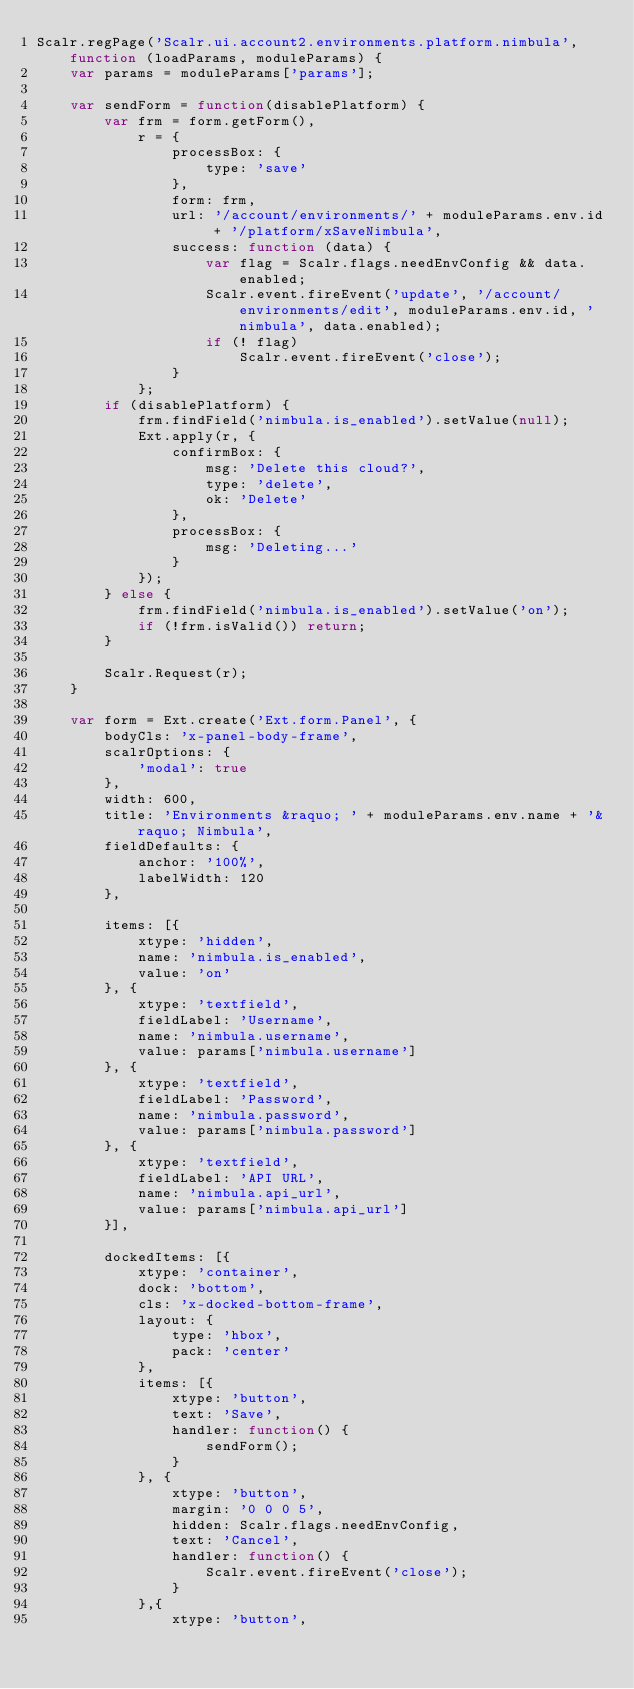Convert code to text. <code><loc_0><loc_0><loc_500><loc_500><_JavaScript_>Scalr.regPage('Scalr.ui.account2.environments.platform.nimbula', function (loadParams, moduleParams) {
	var params = moduleParams['params'];

	var sendForm = function(disablePlatform) {
		var frm = form.getForm(),
			r = {
				processBox: {
					type: 'save'
				},
				form: frm,
				url: '/account/environments/' + moduleParams.env.id + '/platform/xSaveNimbula',
				success: function (data) {
					var flag = Scalr.flags.needEnvConfig && data.enabled;
					Scalr.event.fireEvent('update', '/account/environments/edit', moduleParams.env.id, 'nimbula', data.enabled);
					if (! flag)
						Scalr.event.fireEvent('close');
				}
			};
		if (disablePlatform) {
			frm.findField('nimbula.is_enabled').setValue(null);
			Ext.apply(r, {
				confirmBox: {
					msg: 'Delete this cloud?',
					type: 'delete',
					ok: 'Delete'
				},
				processBox: {
					msg: 'Deleting...'
				}
			});
		} else {
			frm.findField('nimbula.is_enabled').setValue('on');
			if (!frm.isValid()) return;
		}
		
		Scalr.Request(r);
	}
	
	var form = Ext.create('Ext.form.Panel', {
		bodyCls: 'x-panel-body-frame',
		scalrOptions: {
			'modal': true
		},
		width: 600,
		title: 'Environments &raquo; ' + moduleParams.env.name + '&raquo; Nimbula',
		fieldDefaults: {
			anchor: '100%',
			labelWidth: 120
		},

		items: [{
			xtype: 'hidden',
			name: 'nimbula.is_enabled',
			value: 'on'
		}, {
			xtype: 'textfield',
			fieldLabel: 'Username',
			name: 'nimbula.username',
			value: params['nimbula.username']
		}, {
			xtype: 'textfield',
			fieldLabel: 'Password',
			name: 'nimbula.password',
			value: params['nimbula.password']
		}, {
			xtype: 'textfield',
			fieldLabel: 'API URL',
			name: 'nimbula.api_url',
			value: params['nimbula.api_url']
		}],

		dockedItems: [{
			xtype: 'container',
			dock: 'bottom',
			cls: 'x-docked-bottom-frame',
			layout: {
				type: 'hbox',
				pack: 'center'
			},
			items: [{
				xtype: 'button',
				text: 'Save',
				handler: function() {
					sendForm();
				}
			}, {
				xtype: 'button',
				margin: '0 0 0 5',
				hidden: Scalr.flags.needEnvConfig,
				text: 'Cancel',
				handler: function() {
					Scalr.event.fireEvent('close');
				}
			},{
				xtype: 'button',</code> 